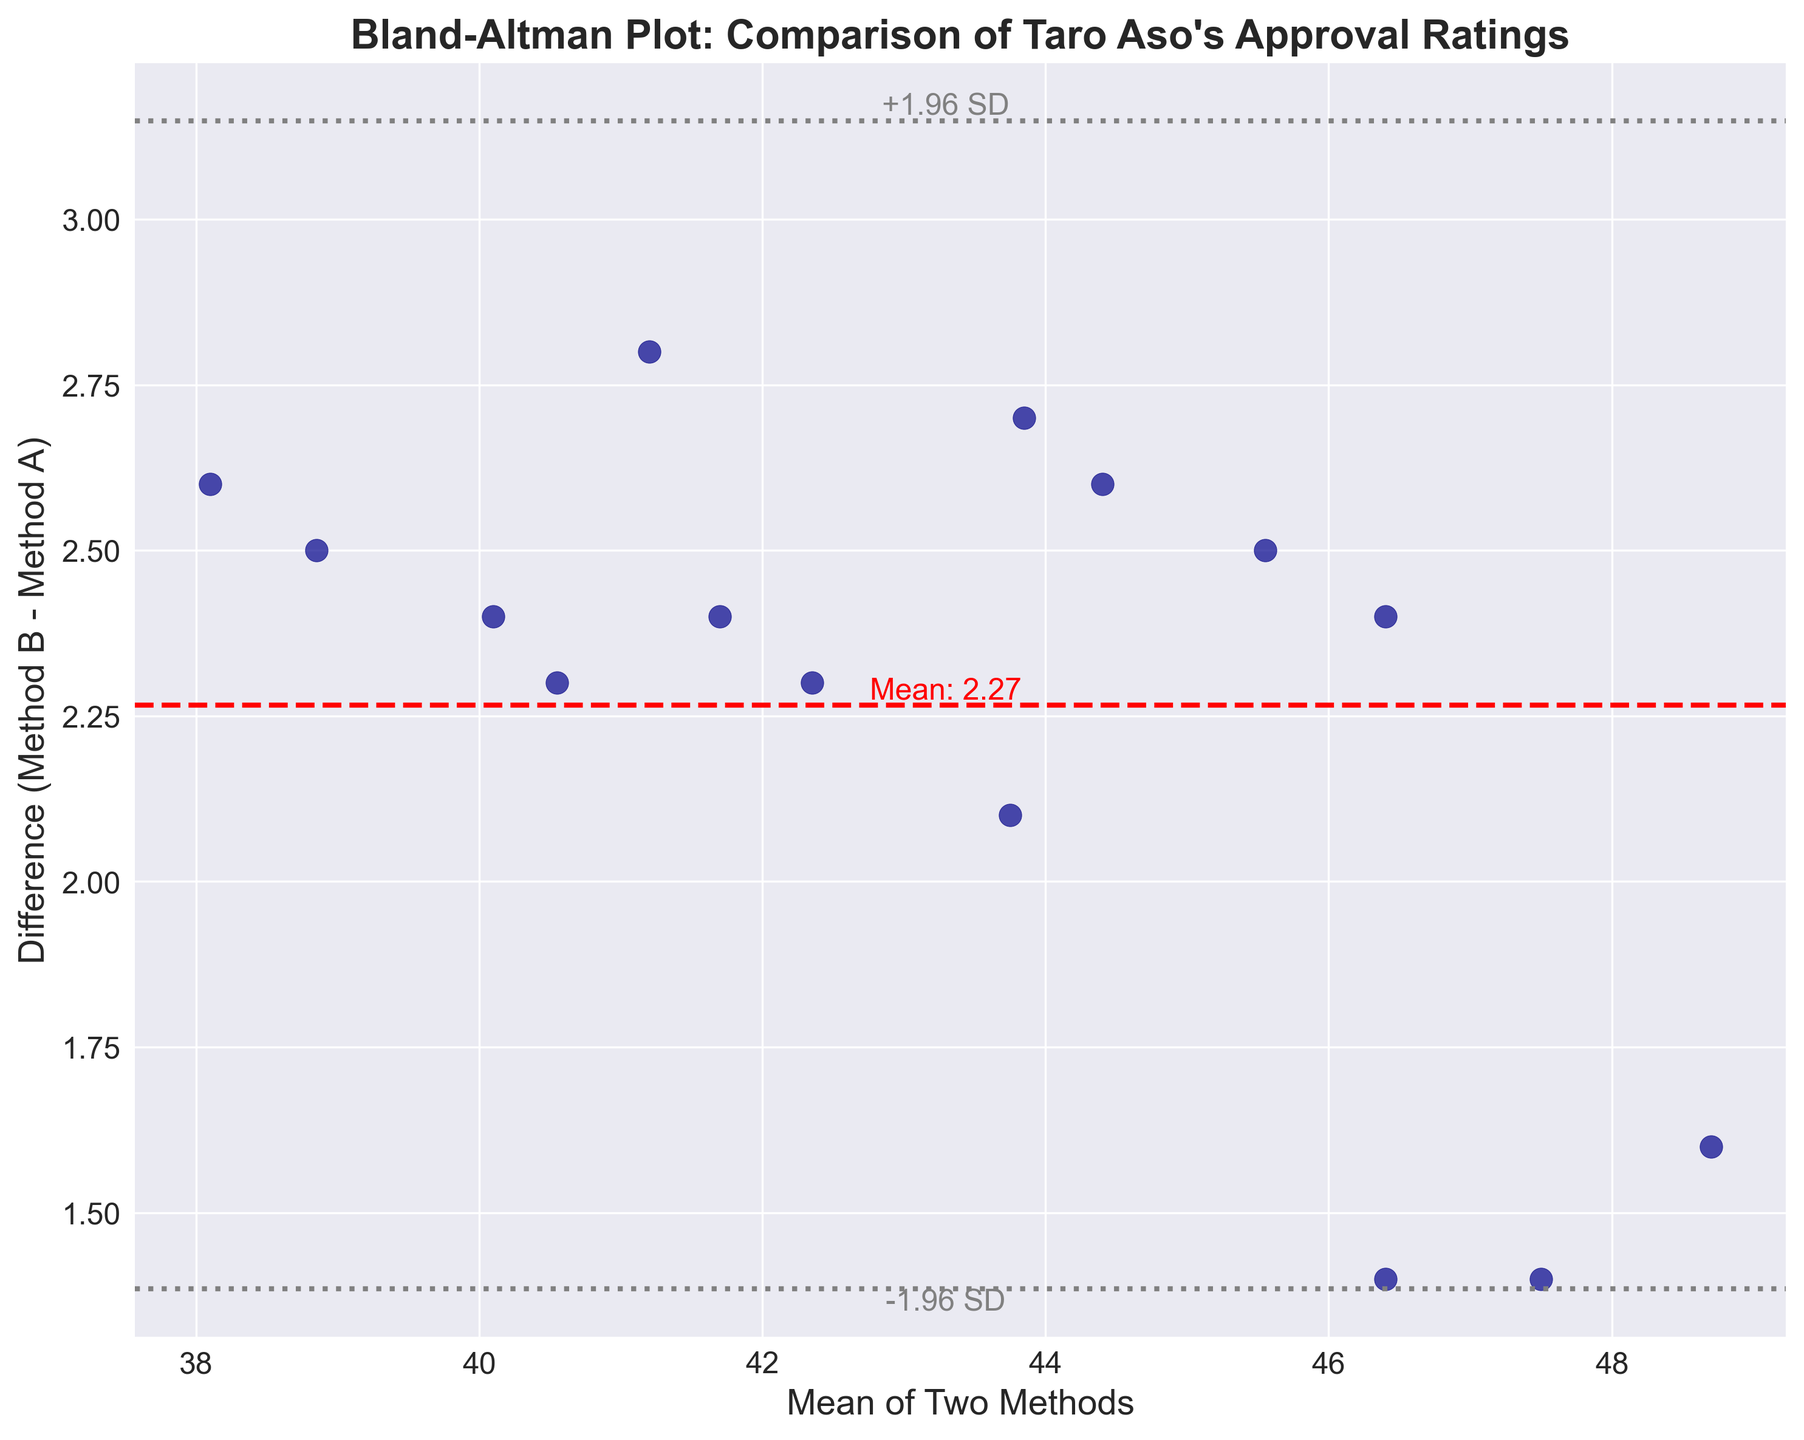What's the title of the plot? The title of the plot is usually located at the top-center of the figure and provides a brief description of what the plot represents. In this case, it describes the nature of the data comparison.
Answer: Bland-Altman Plot: Comparison of Taro Aso's Approval Ratings How many data points are in the plot? To determine the number of data points, count the number of scattered dots on the figure. Each dot represents an approval rating pair from the two methods.
Answer: 15 What's the color of the data points? The color of the data points can be identified by visually inspecting the plot. They appear as small scattered dots.
Answer: Dark blue What is labeled on the x-axis? The x-axis label is located directly below the x-axis and describes what the axis represents. In this plot, it specifies the average approval ratings from the two methods.
Answer: Mean of Two Methods What is labeled on the y-axis? The y-axis label is located directly to the left of the y-axis and describes what the axis represents. In this plot, it specifies the difference between approval ratings from Method B and Method A.
Answer: Difference (Method B - Method A) What is the mean difference between Method B and Method A? The mean difference is indicated by the middle horizontal line and often labeled in the plot. It represents the average deviation of Method B's measurements from Method A's.
Answer: Mean: 2.21 What's the range of the limits of agreement shown in the plot? The limits of agreement are represented by the two gray horizontal lines (±1.96 standard deviations from the mean difference). Subtract the lower limit from the upper limit to find the range.
Answer: +1.96 SD and -1.96 SD What data point has the largest positive difference? Identify the data point with the highest y-value (difference) on the plot. This represents the biggest positive deviation between Method B and Method A.
Answer: Top-most data point Describe the general trend of the differences as the mean approval rating increases. Look at the scattered data points and observe the direction in which the differences move as the mean values on the x-axis increase. This will help identify any patterns in the differences.
Answer: There seems to be no obvious trend; the differences are relatively scattered around the mean difference Are there any data points outside the limits of agreement? Check if any of the data points lie above the upper gray line or below the lower gray line (limits of agreement) to see if there are any outliers.
Answer: No 